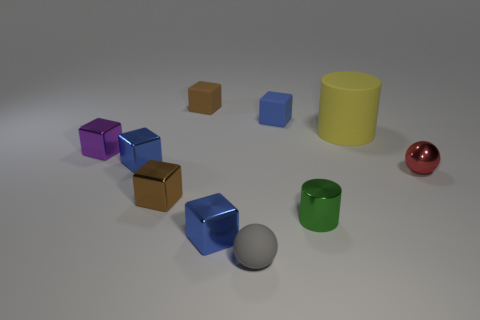Does the tiny gray ball have the same material as the small purple object?
Your response must be concise. No. Do the purple object and the brown shiny thing have the same shape?
Give a very brief answer. Yes. The tiny cylinder has what color?
Keep it short and to the point. Green. How many things are either tiny red things or big yellow matte spheres?
Your answer should be compact. 1. Are there any other things that are made of the same material as the gray object?
Provide a short and direct response. Yes. Are there fewer green cylinders that are in front of the tiny gray sphere than tiny metal spheres?
Make the answer very short. Yes. Are there more tiny metallic cylinders that are behind the large rubber cylinder than green metal cylinders that are behind the small brown matte cube?
Offer a very short reply. No. Is there anything else that is the same color as the rubber ball?
Offer a terse response. No. There is a sphere that is on the right side of the small gray matte ball; what material is it?
Your answer should be compact. Metal. Does the yellow matte cylinder have the same size as the shiny cylinder?
Give a very brief answer. No. 